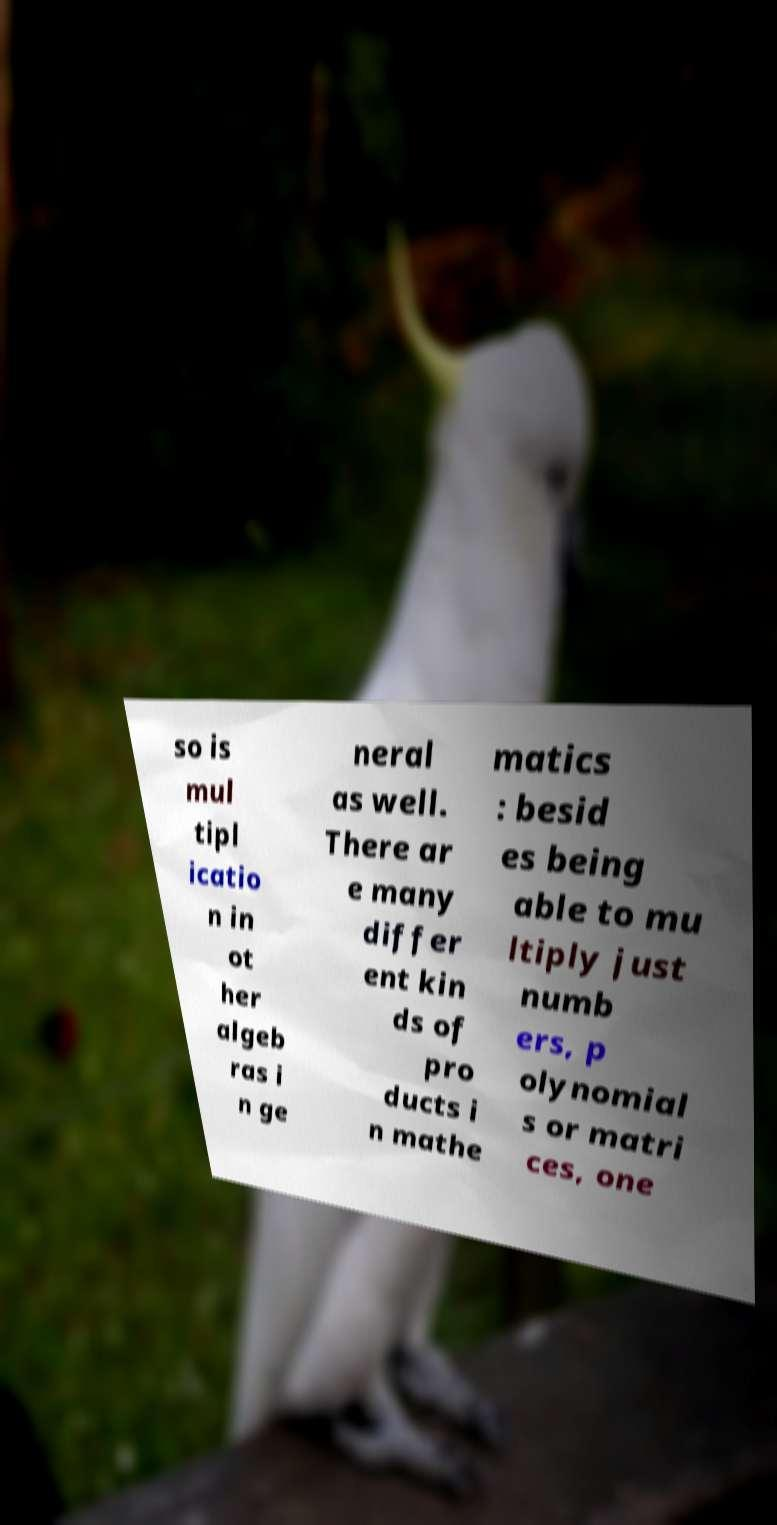Can you read and provide the text displayed in the image?This photo seems to have some interesting text. Can you extract and type it out for me? so is mul tipl icatio n in ot her algeb ras i n ge neral as well. There ar e many differ ent kin ds of pro ducts i n mathe matics : besid es being able to mu ltiply just numb ers, p olynomial s or matri ces, one 